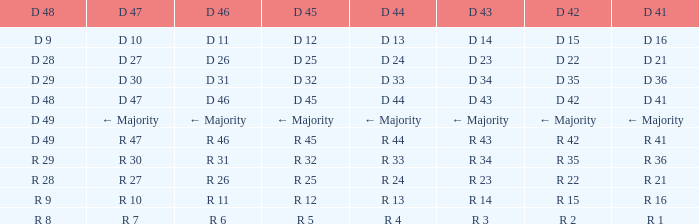Specify the d 47 when it has a d 41 with r 3 R 30. 